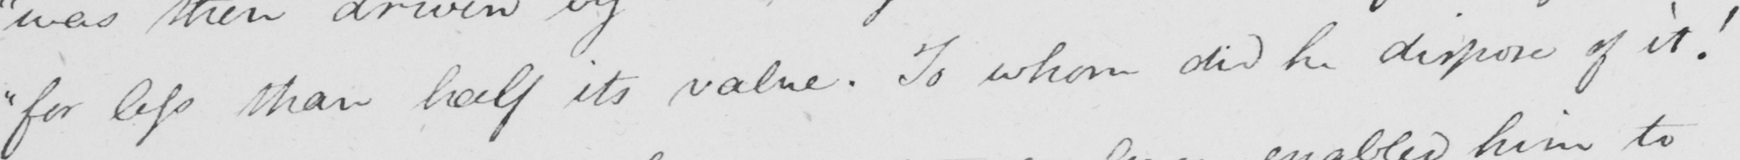Can you tell me what this handwritten text says? " for less than half its value . To whom did he dispose of it ! 